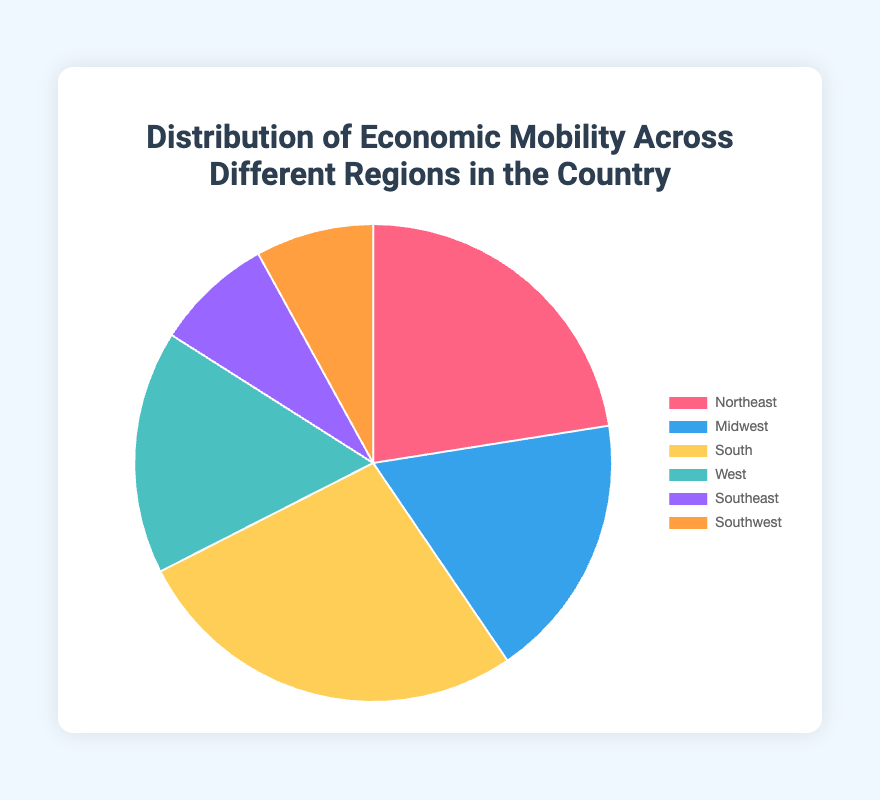What region has the highest percentage of economic mobility? The highest percentage of economic mobility can be directly observed from the pie chart. The region with the largest slice, representing 27%, is the South.
Answer: South Which region has the lowest percentage of economic mobility? The lowest percentage of economic mobility is shown by the smallest slice in the pie chart, which represents 8%. Both the Southeast and Southwest regions have this percentage.
Answer: Southeast, Southwest What is the combined percentage of economic mobility for the Northeast and Midwest regions? To find the combined percentage, add the individual percentages of the Northeast (22.5%) and Midwest (18.0%). 22.5 + 18.0 = 40.5
Answer: 40.5 How does the percentage of economic mobility in the South compare to that in the West? The percentage of economic mobility in the South is 27.0%, while in the West, it's 16.5%. The South's percentage is significantly higher.
Answer: South is higher What is the percentage difference in economic mobility between the Northeast and Southeast regions? Subtract the Southeast's percentage (8.0%) from the Northeast's percentage (22.5%). 22.5 - 8.0 = 14.5
Answer: 14.5 Which regions have an equal percentage of economic mobility, and what is that percentage? The pie chart shows that the Southeast and Southwest regions both have a percentage of 8.0%.
Answer: Southeast, Southwest; 8.0 What is the sum of the percentages of economic mobility for regions in the South and Southeast? Add the percentages for the South (27.0%) and Southeast (8.0%). 27.0 + 8.0 = 35.0
Answer: 35.0 What color represents the Midwest region in the pie chart? The visual attribute of color for the Midwest region corresponds to the second segment of the pie chart, which is blue.
Answer: Blue 